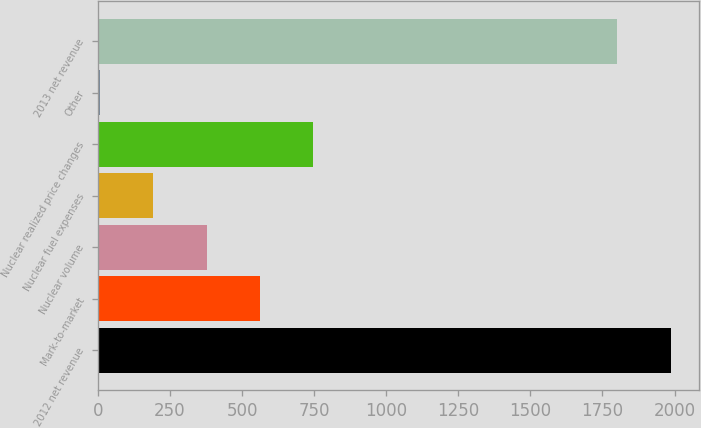Convert chart to OTSL. <chart><loc_0><loc_0><loc_500><loc_500><bar_chart><fcel>2012 net revenue<fcel>Mark-to-market<fcel>Nuclear volume<fcel>Nuclear fuel expenses<fcel>Nuclear realized price changes<fcel>Other<fcel>2013 net revenue<nl><fcel>1986.6<fcel>561.8<fcel>377.2<fcel>192.6<fcel>746.4<fcel>8<fcel>1802<nl></chart> 